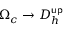<formula> <loc_0><loc_0><loc_500><loc_500>\Omega _ { c } \to D _ { h } ^ { u p }</formula> 